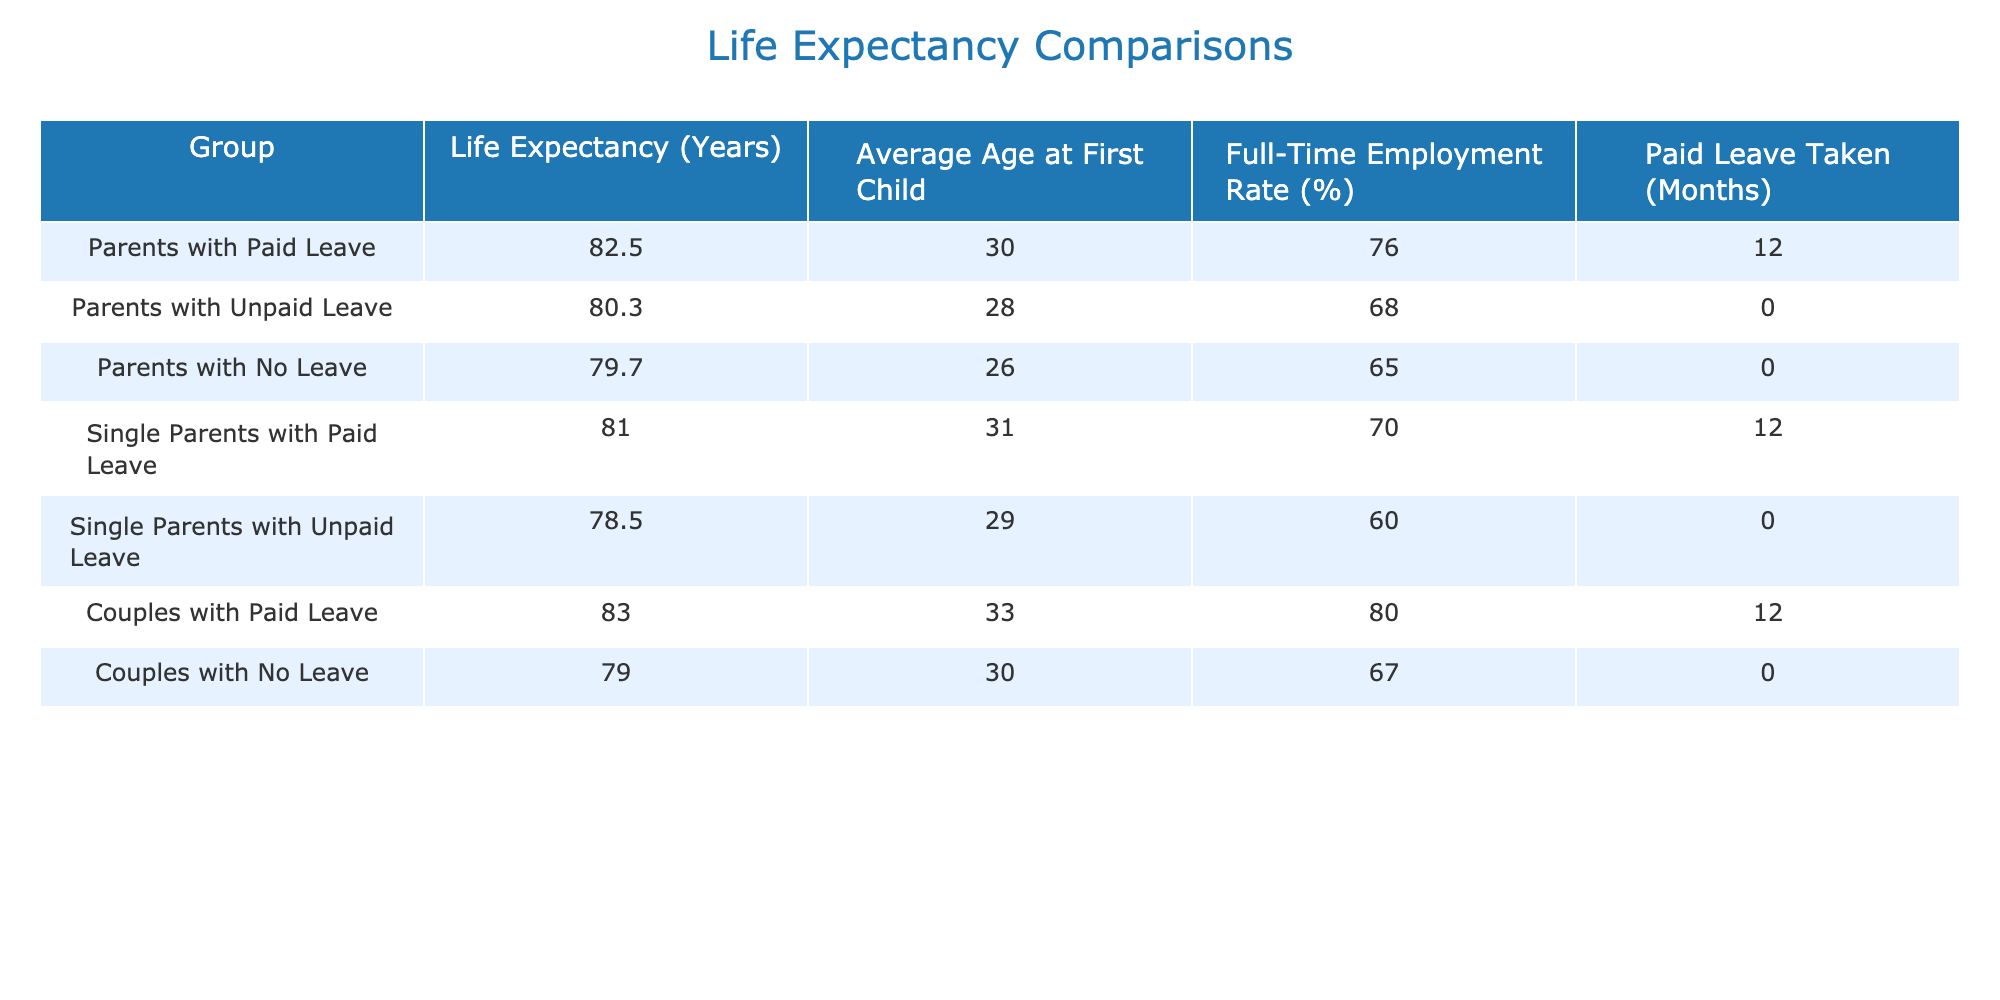What is the life expectancy for parents with paid leave? According to the table, the life expectancy for parents with paid leave is specified in the first row under "Life Expectancy (Years)" as 82.5 years.
Answer: 82.5 How many months of paid leave did couples take, and what is their life expectancy? The table shows that couples with paid leave took 12 months of leave, and their life expectancy is 83.0 years, as indicated in the row corresponding to "Couples with Paid Leave."
Answer: 12 months, 83.0 Is it true that single parents who took unpaid leave have a higher life expectancy compared to parents with no leave? The life expectancy for single parents with unpaid leave is 78.5 years, while the life expectancy for parents with no leave is 79.7 years. Since 78.5 is less than 79.7, the statement is false.
Answer: No What is the difference in life expectancy between parents with paid leave and parents with no leave? The life expectancy for parents with paid leave is 82.5 years, while for those with no leave it is 79.7 years. The difference is calculated as 82.5 - 79.7 = 2.8 years.
Answer: 2.8 years What is the average life expectancy for all groups of parents? To get the average, sum all the life expectancies: 82.5 + 80.3 + 79.7 + 81.0 + 78.5 + 83.0 + 79.0 = 464.0 and there are 7 groups, so the average is 464.0 / 7 = 66.29.
Answer: 66.29 How does the full-time employment rate of parents with no leave compare to those with paid leave? The full-time employment rate for parents with no leave is 67%, while for parents with paid leave it is 76%. Thus, parents with paid leave have a higher full-time employment rate.
Answer: Higher What is the life expectancy of couples with no leave? Referring to the table, the life expectancy for couples with no leave is listed as 79.0 years in the corresponding row.
Answer: 79.0 Do all groups of parents who took paid leave have a life expectancy above 80 years? Looking at the table, parents with paid leave (82.5 years), single parents with paid leave (81.0 years), and couples with paid leave (83.0 years) all have life expectancies above 80 years. Hence, the statement is true for all subgroups.
Answer: Yes 